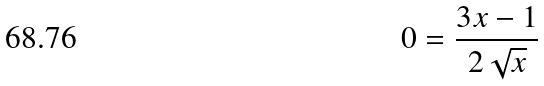<formula> <loc_0><loc_0><loc_500><loc_500>0 = \frac { 3 x - 1 } { 2 \sqrt { x } }</formula> 